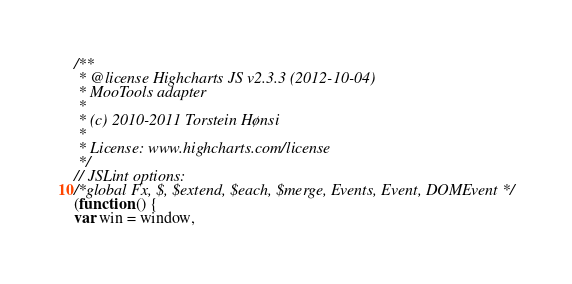<code> <loc_0><loc_0><loc_500><loc_500><_JavaScript_>/**
 * @license Highcharts JS v2.3.3 (2012-10-04)
 * MooTools adapter
 *
 * (c) 2010-2011 Torstein Hønsi
 *
 * License: www.highcharts.com/license
 */
// JSLint options:
/*global Fx, $, $extend, $each, $merge, Events, Event, DOMEvent */
(function () {
var win = window,</code> 